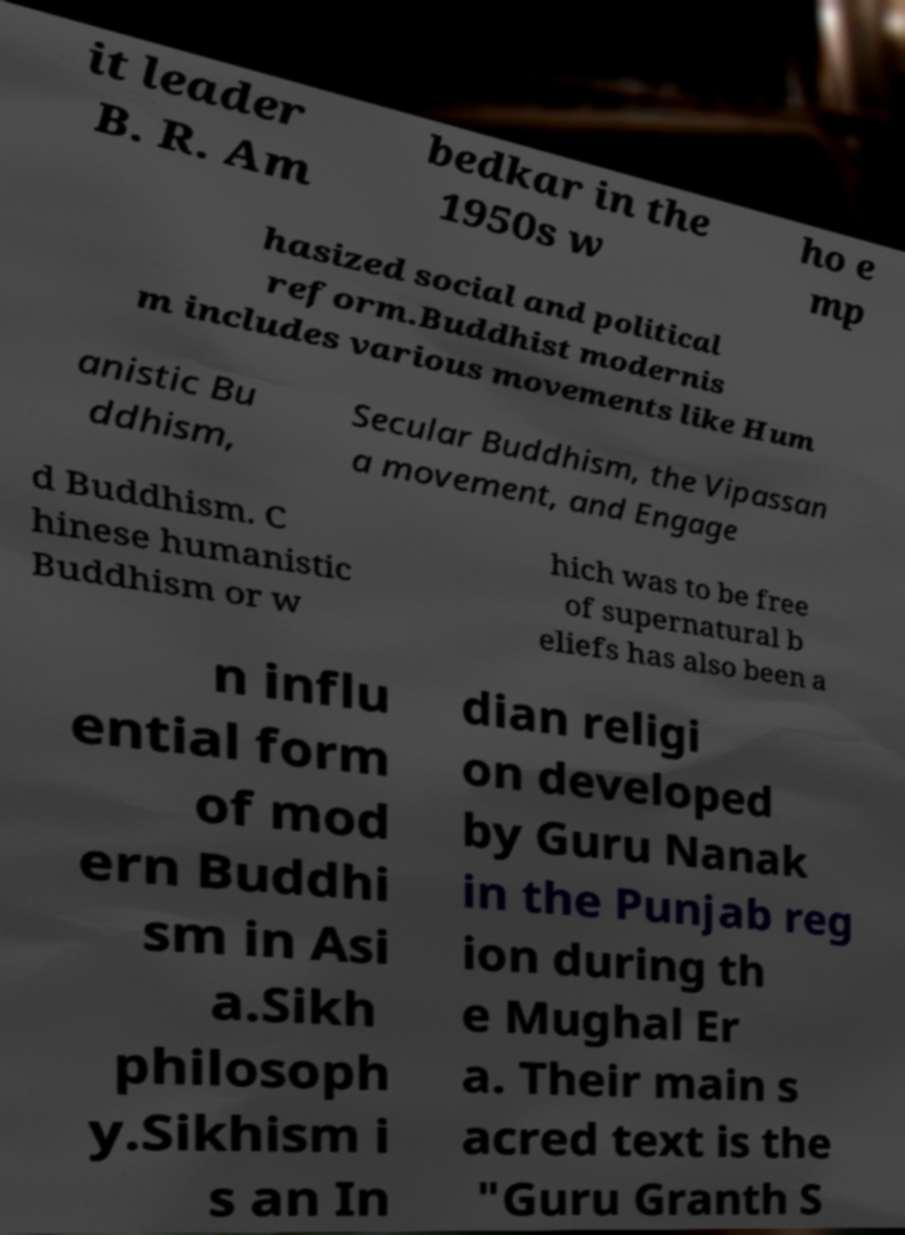Can you accurately transcribe the text from the provided image for me? it leader B. R. Am bedkar in the 1950s w ho e mp hasized social and political reform.Buddhist modernis m includes various movements like Hum anistic Bu ddhism, Secular Buddhism, the Vipassan a movement, and Engage d Buddhism. C hinese humanistic Buddhism or w hich was to be free of supernatural b eliefs has also been a n influ ential form of mod ern Buddhi sm in Asi a.Sikh philosoph y.Sikhism i s an In dian religi on developed by Guru Nanak in the Punjab reg ion during th e Mughal Er a. Their main s acred text is the "Guru Granth S 